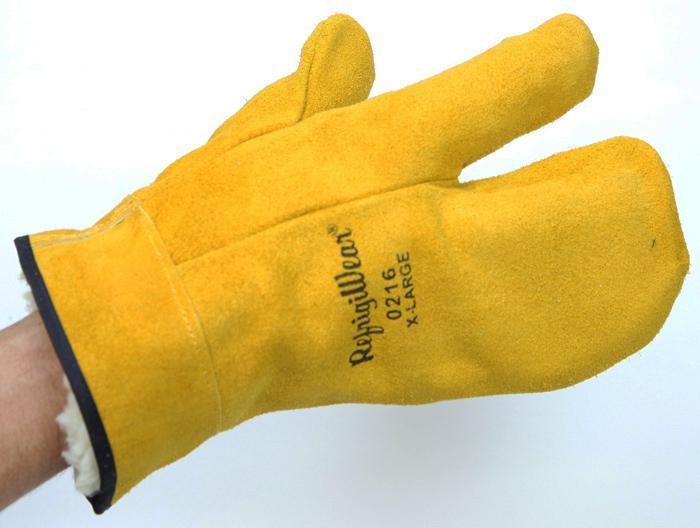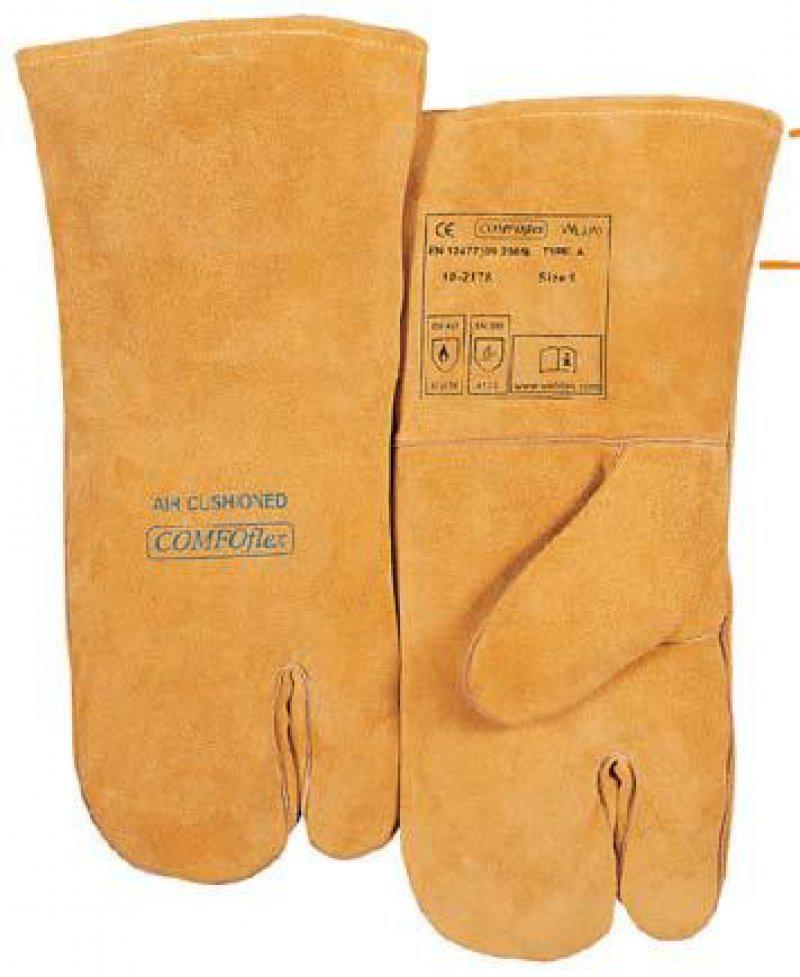The first image is the image on the left, the second image is the image on the right. Analyze the images presented: Is the assertion "In one image a pair of yellow-gold gloves are shown, the back view of one and the front view of the other, while the second image shows at least one similar glove with a human arm extended." valid? Answer yes or no. Yes. The first image is the image on the left, the second image is the image on the right. Given the left and right images, does the statement "Someone is wearing one of the gloves." hold true? Answer yes or no. Yes. 